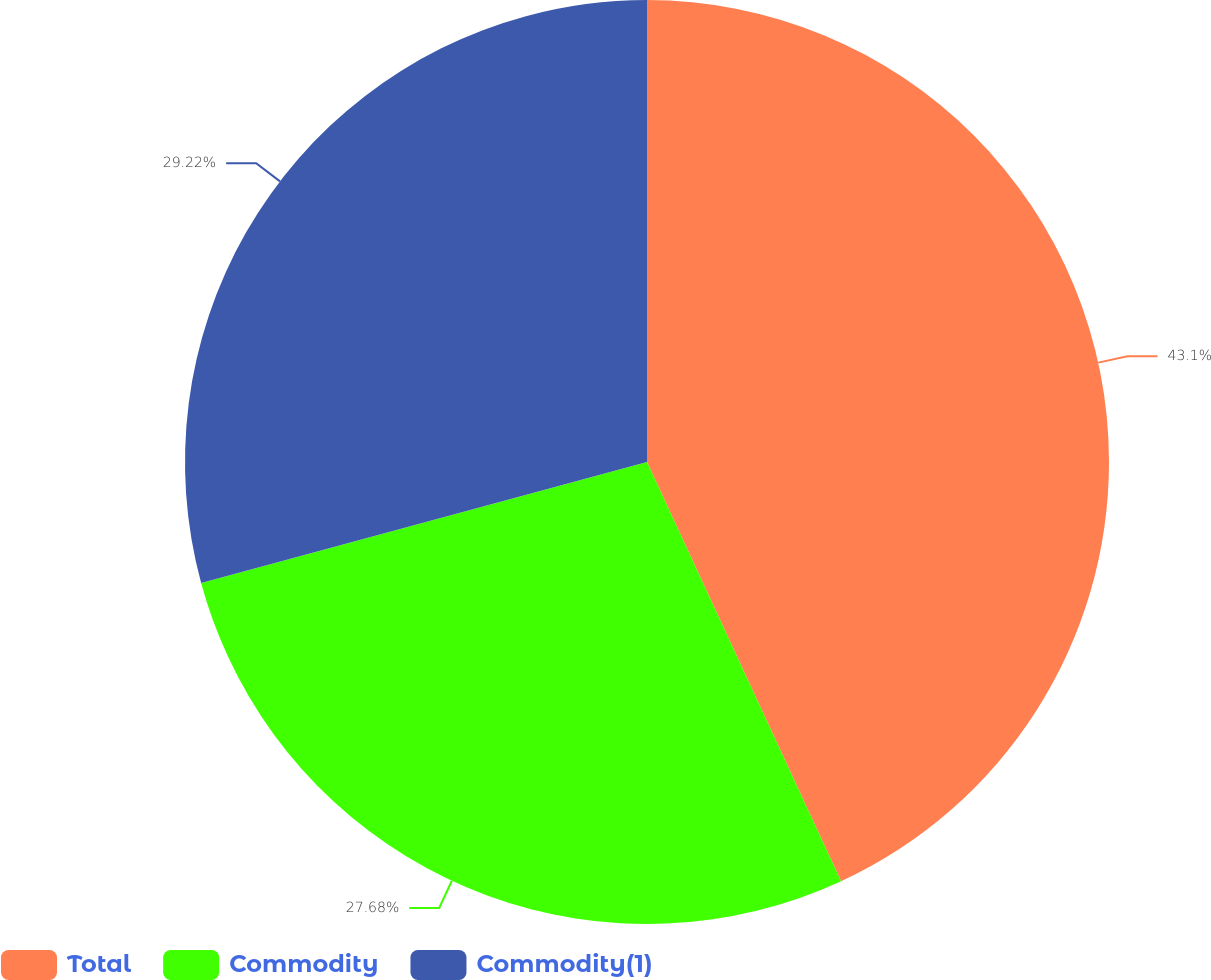<chart> <loc_0><loc_0><loc_500><loc_500><pie_chart><fcel>Total<fcel>Commodity<fcel>Commodity(1)<nl><fcel>43.1%<fcel>27.68%<fcel>29.22%<nl></chart> 